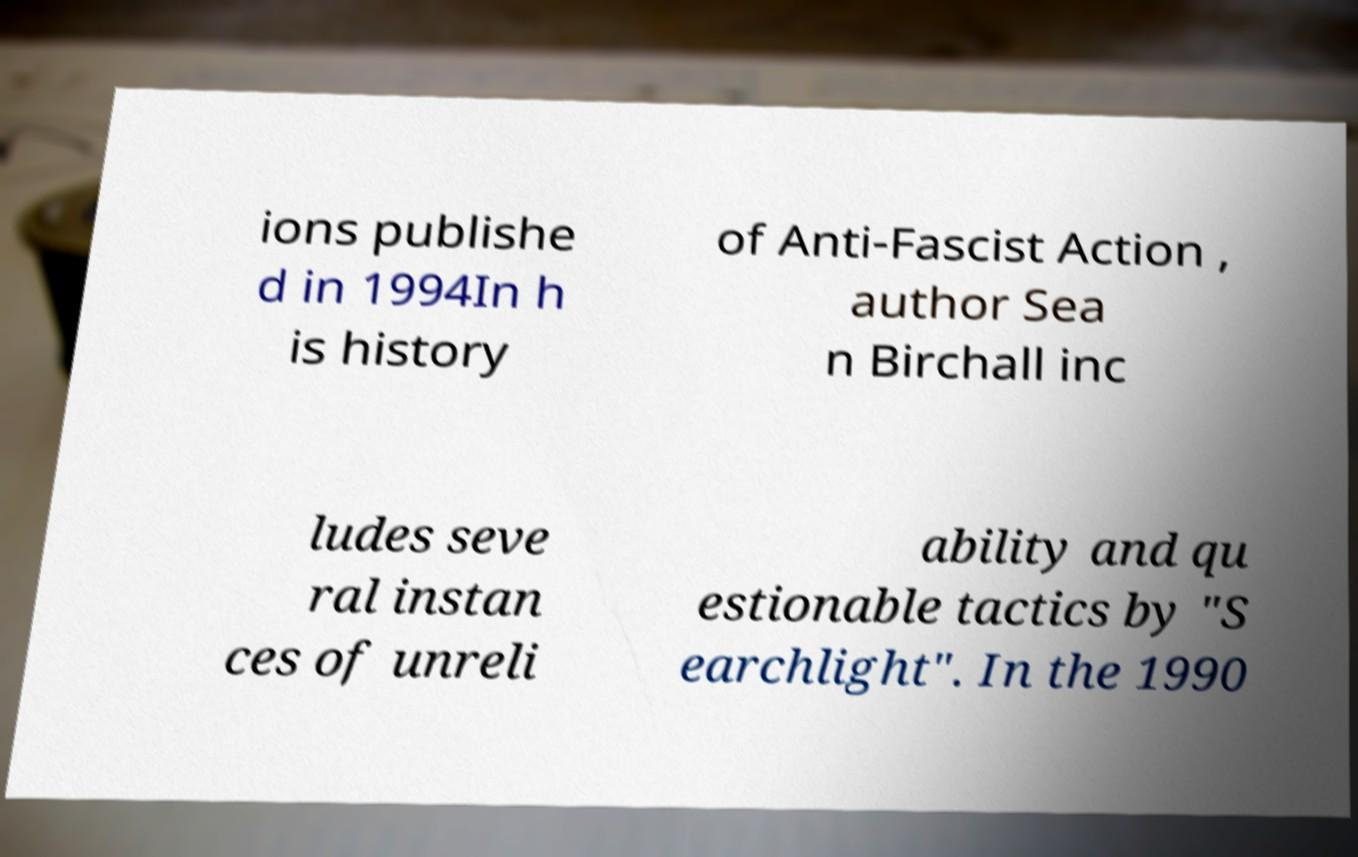Could you assist in decoding the text presented in this image and type it out clearly? ions publishe d in 1994In h is history of Anti-Fascist Action , author Sea n Birchall inc ludes seve ral instan ces of unreli ability and qu estionable tactics by "S earchlight". In the 1990 